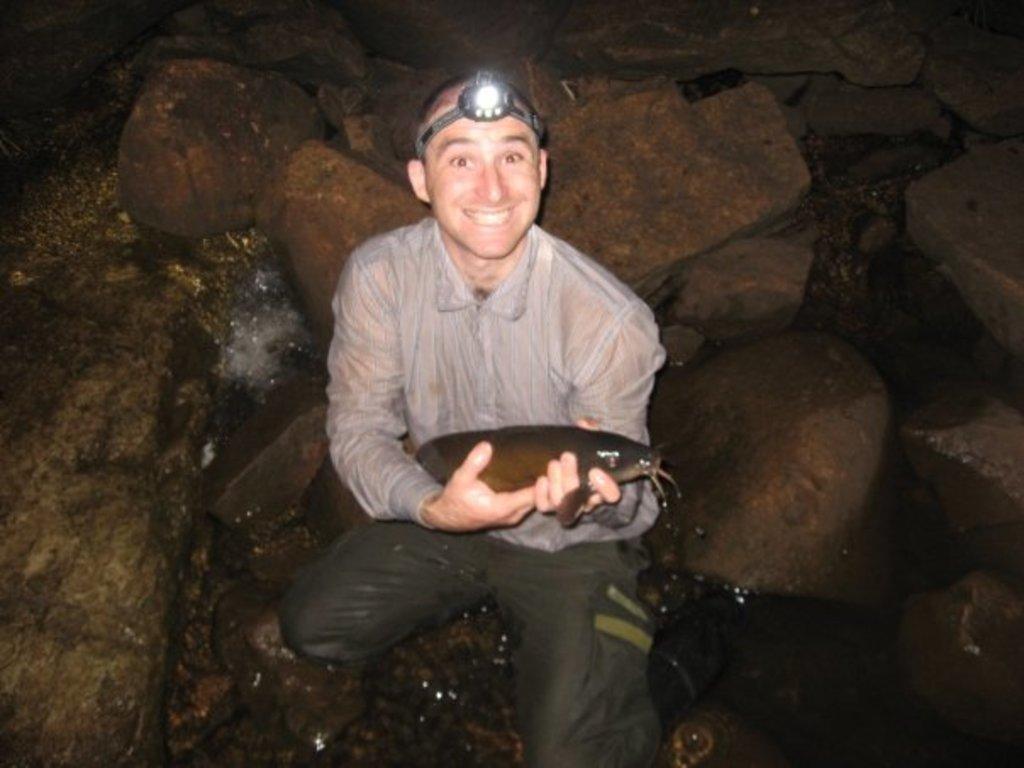How would you summarize this image in a sentence or two? In this image I can see the person is holding something and wearing led-headlight. I can see few rocks and water. 